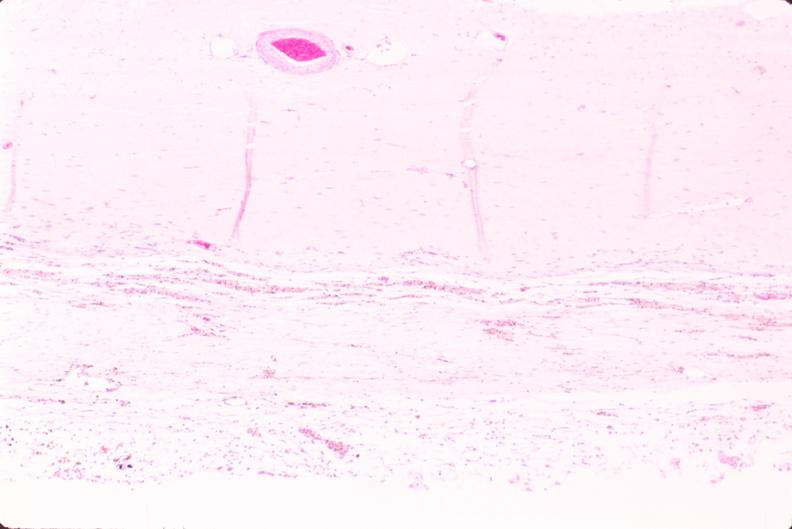does this image show brain, infarct due to ruptured saccular aneurysm and thrombosis of right middle cerebral artery?
Answer the question using a single word or phrase. Yes 